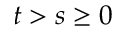Convert formula to latex. <formula><loc_0><loc_0><loc_500><loc_500>t > s \geq 0</formula> 